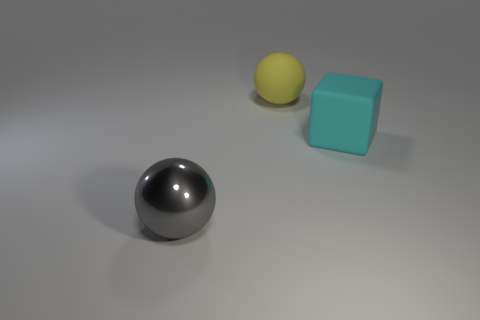There is a matte object that is the same shape as the gray metallic object; what size is it? The matte object appears to be the same size as the metallic sphere, which means it is of medium size in comparison to other objects present in the image. 